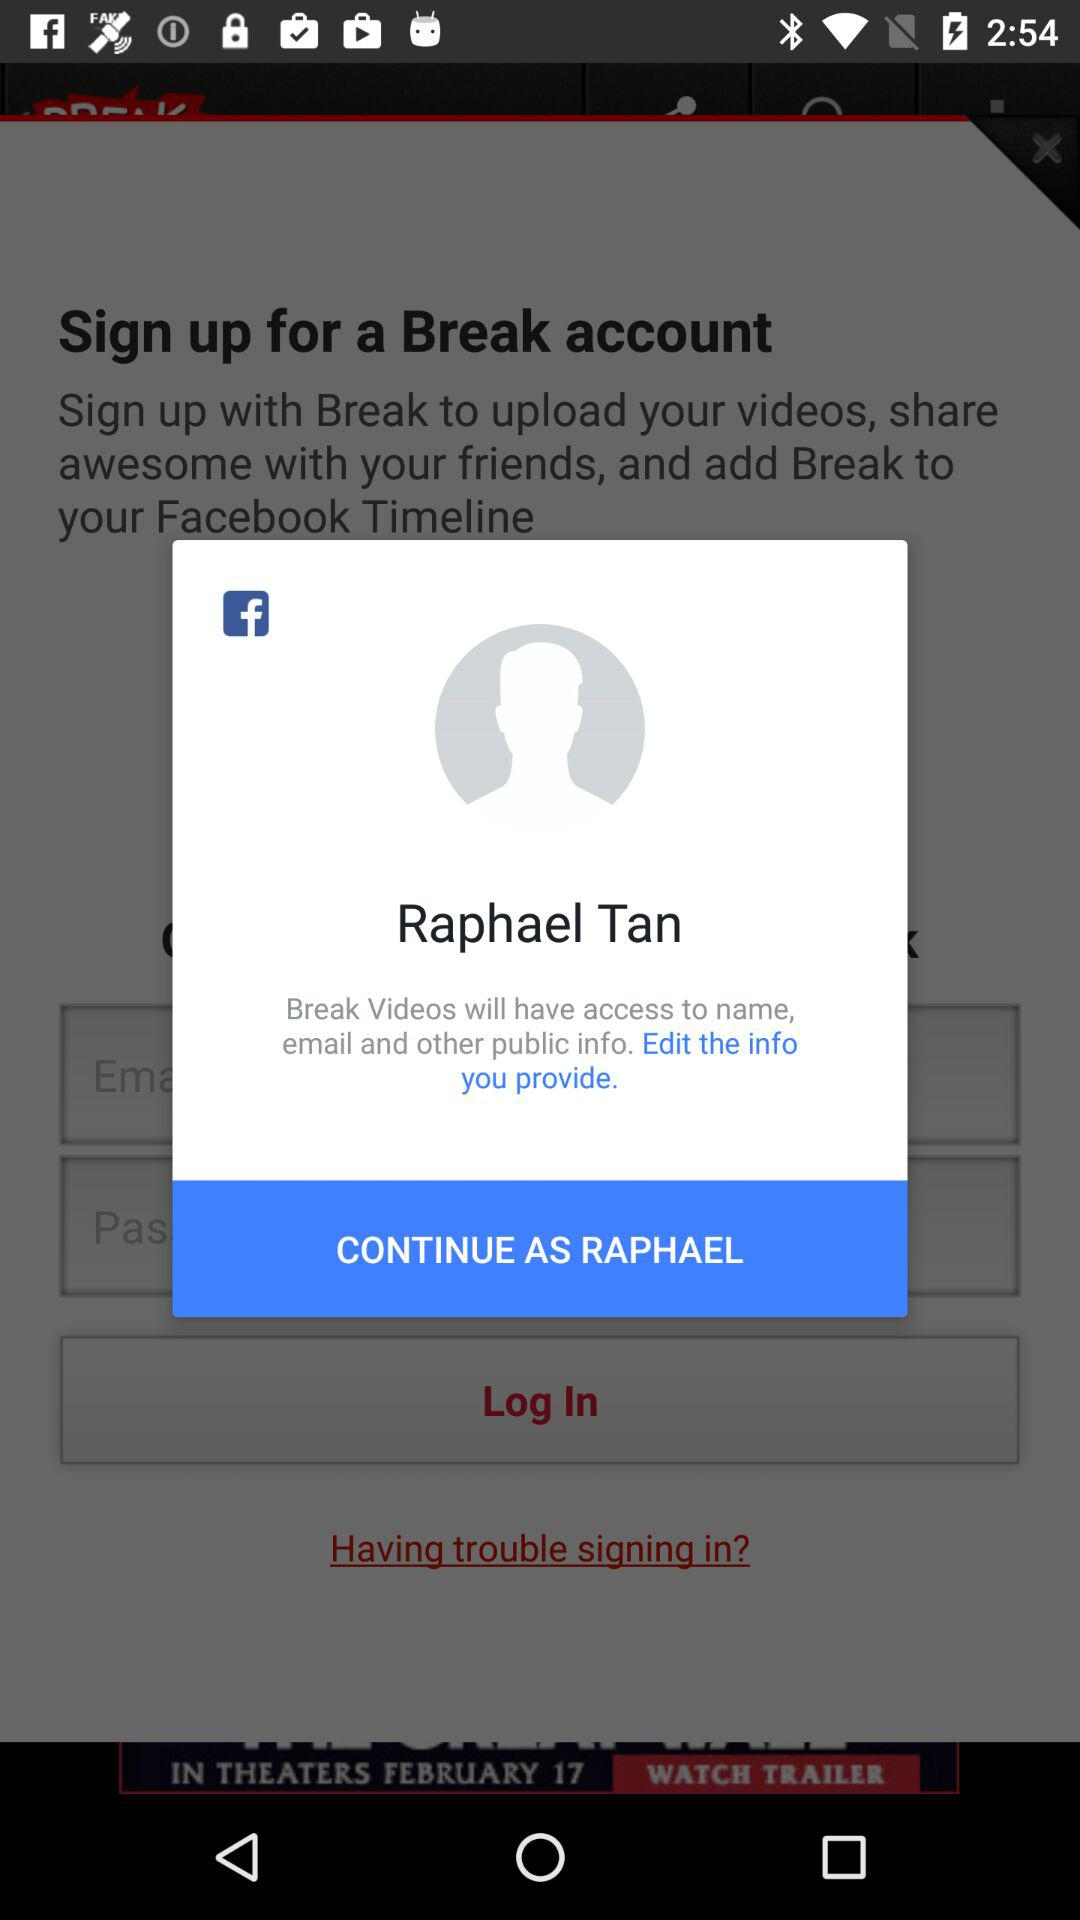What is the name of the user? The name of the user is "Raphael Tan". 